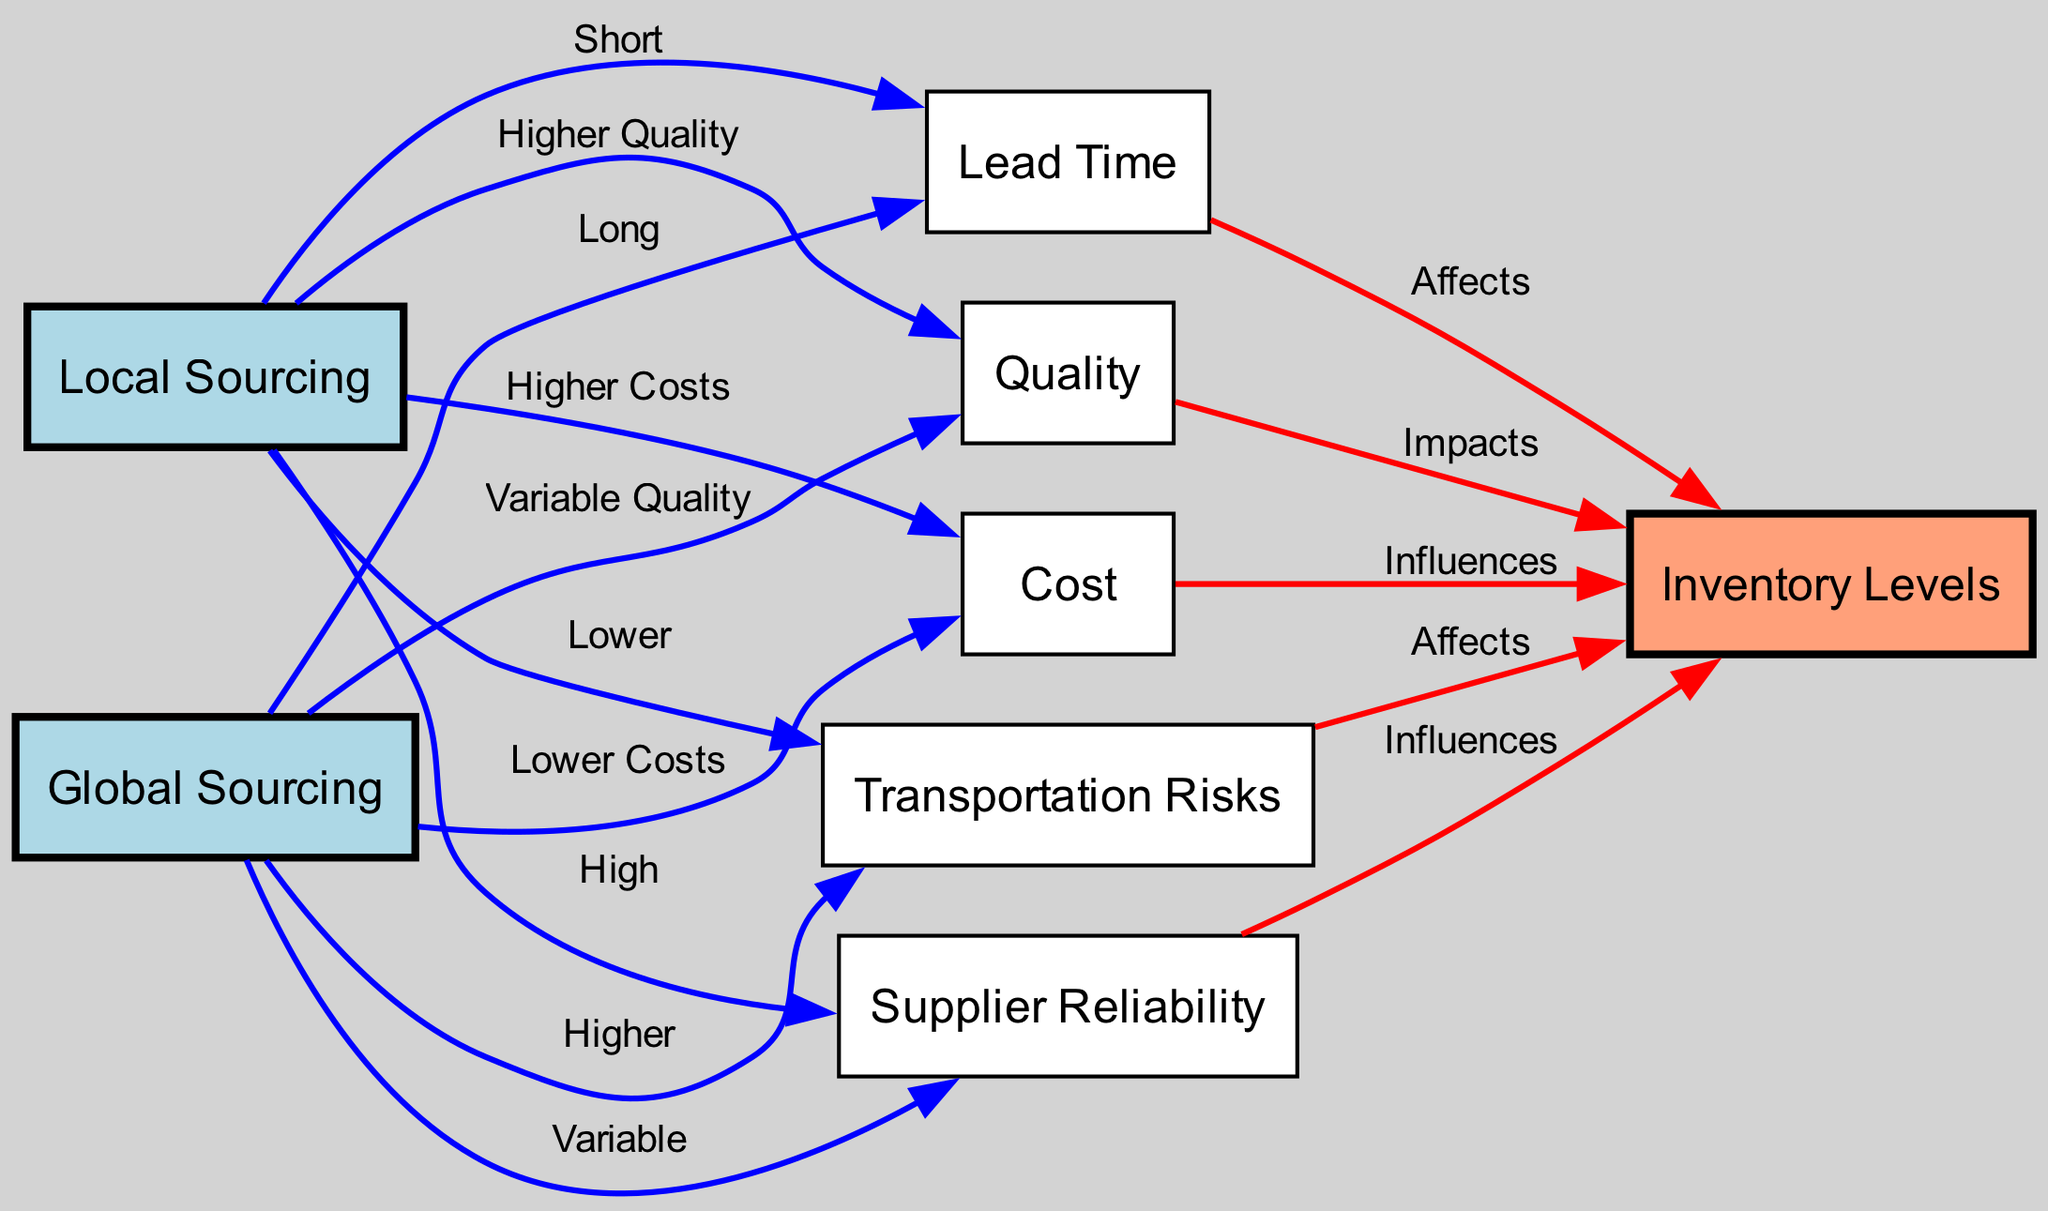What is the relationship between local sourcing and lead time? The edge connecting "local sourcing" and "lead time" states "Short," indicating that local sourcing results in a shorter lead time compared to other methods.
Answer: Short How many edges are there in the diagram? By counting all the connections (edges) that connect nodes, we find there are 14 edges in total.
Answer: 14 What type of quality is associated with global sourcing? The edge from "global sourcing" to "quality" states "Variable Quality," which shows that the quality from global sourcing can vary.
Answer: Variable Quality Which sourcing strategy has higher supplier reliability? The edge from "local sourcing" to "supplier reliability" indicates "High," suggesting that local sourcing tends to have more reliable suppliers.
Answer: High What effect does transportation risk have on inventory levels? Transportation risks are shown to "Affect" inventory levels, meaning that higher transportation risks can lead to potential disruptions in inventory management.
Answer: Affects How does cost influence inventory levels? The diagram shows that cost "Influences" inventory levels, demonstrating that higher or lower costs can impact the amount of inventory kept on hand.
Answer: Influences What is the lead time for global sourcing? The connection indicates that the lead time for global sourcing is described as "Long," meaning it typically takes a longer time to procure materials globally compared to locally.
Answer: Long What strategy results in lower transportation risks? The edge from "local sourcing" to "transportation risks" states "Lower," indicating that local sourcing has reduced transportation risks compared to global sourcing.
Answer: Lower Which sourcing option has the potential for higher quality? The edge from "local sourcing" to "quality" indicates "Higher Quality," meaning local sourcing is associated with better quality materials than global sourcing.
Answer: Higher Quality 